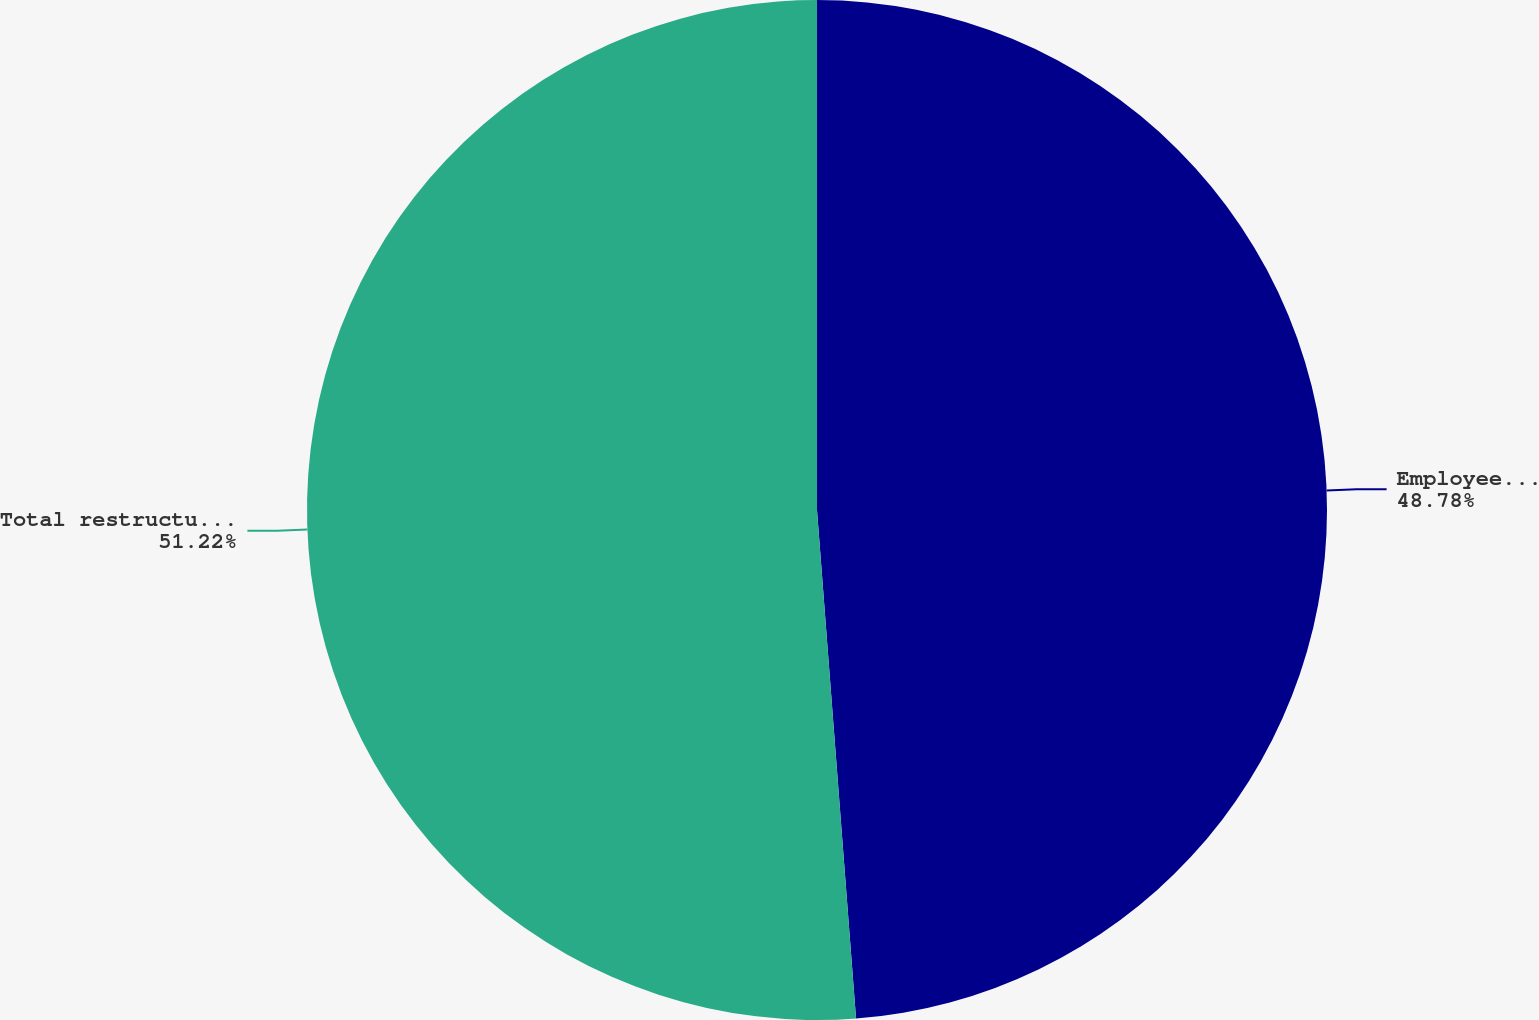<chart> <loc_0><loc_0><loc_500><loc_500><pie_chart><fcel>Employee related costs<fcel>Total restructuring charges<nl><fcel>48.78%<fcel>51.22%<nl></chart> 